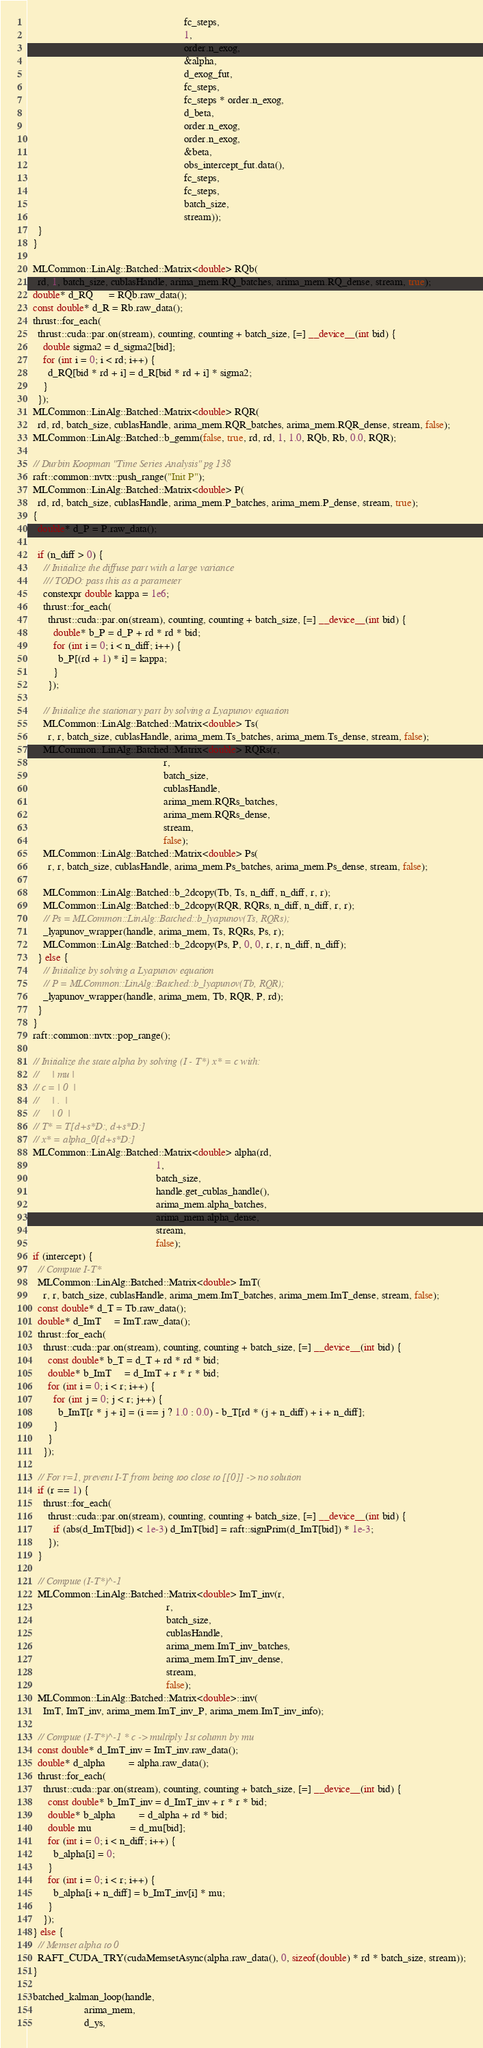<code> <loc_0><loc_0><loc_500><loc_500><_Cuda_>                                                             fc_steps,
                                                             1,
                                                             order.n_exog,
                                                             &alpha,
                                                             d_exog_fut,
                                                             fc_steps,
                                                             fc_steps * order.n_exog,
                                                             d_beta,
                                                             order.n_exog,
                                                             order.n_exog,
                                                             &beta,
                                                             obs_intercept_fut.data(),
                                                             fc_steps,
                                                             fc_steps,
                                                             batch_size,
                                                             stream));
    }
  }

  MLCommon::LinAlg::Batched::Matrix<double> RQb(
    rd, 1, batch_size, cublasHandle, arima_mem.RQ_batches, arima_mem.RQ_dense, stream, true);
  double* d_RQ      = RQb.raw_data();
  const double* d_R = Rb.raw_data();
  thrust::for_each(
    thrust::cuda::par.on(stream), counting, counting + batch_size, [=] __device__(int bid) {
      double sigma2 = d_sigma2[bid];
      for (int i = 0; i < rd; i++) {
        d_RQ[bid * rd + i] = d_R[bid * rd + i] * sigma2;
      }
    });
  MLCommon::LinAlg::Batched::Matrix<double> RQR(
    rd, rd, batch_size, cublasHandle, arima_mem.RQR_batches, arima_mem.RQR_dense, stream, false);
  MLCommon::LinAlg::Batched::b_gemm(false, true, rd, rd, 1, 1.0, RQb, Rb, 0.0, RQR);

  // Durbin Koopman "Time Series Analysis" pg 138
  raft::common::nvtx::push_range("Init P");
  MLCommon::LinAlg::Batched::Matrix<double> P(
    rd, rd, batch_size, cublasHandle, arima_mem.P_batches, arima_mem.P_dense, stream, true);
  {
    double* d_P = P.raw_data();

    if (n_diff > 0) {
      // Initialize the diffuse part with a large variance
      /// TODO: pass this as a parameter
      constexpr double kappa = 1e6;
      thrust::for_each(
        thrust::cuda::par.on(stream), counting, counting + batch_size, [=] __device__(int bid) {
          double* b_P = d_P + rd * rd * bid;
          for (int i = 0; i < n_diff; i++) {
            b_P[(rd + 1) * i] = kappa;
          }
        });

      // Initialize the stationary part by solving a Lyapunov equation
      MLCommon::LinAlg::Batched::Matrix<double> Ts(
        r, r, batch_size, cublasHandle, arima_mem.Ts_batches, arima_mem.Ts_dense, stream, false);
      MLCommon::LinAlg::Batched::Matrix<double> RQRs(r,
                                                     r,
                                                     batch_size,
                                                     cublasHandle,
                                                     arima_mem.RQRs_batches,
                                                     arima_mem.RQRs_dense,
                                                     stream,
                                                     false);
      MLCommon::LinAlg::Batched::Matrix<double> Ps(
        r, r, batch_size, cublasHandle, arima_mem.Ps_batches, arima_mem.Ps_dense, stream, false);

      MLCommon::LinAlg::Batched::b_2dcopy(Tb, Ts, n_diff, n_diff, r, r);
      MLCommon::LinAlg::Batched::b_2dcopy(RQR, RQRs, n_diff, n_diff, r, r);
      // Ps = MLCommon::LinAlg::Batched::b_lyapunov(Ts, RQRs);
      _lyapunov_wrapper(handle, arima_mem, Ts, RQRs, Ps, r);
      MLCommon::LinAlg::Batched::b_2dcopy(Ps, P, 0, 0, r, r, n_diff, n_diff);
    } else {
      // Initialize by solving a Lyapunov equation
      // P = MLCommon::LinAlg::Batched::b_lyapunov(Tb, RQR);
      _lyapunov_wrapper(handle, arima_mem, Tb, RQR, P, rd);
    }
  }
  raft::common::nvtx::pop_range();

  // Initialize the state alpha by solving (I - T*) x* = c with:
  //     | mu |
  // c = | 0  |
  //     | .  |
  //     | 0  |
  // T* = T[d+s*D:, d+s*D:]
  // x* = alpha_0[d+s*D:]
  MLCommon::LinAlg::Batched::Matrix<double> alpha(rd,
                                                  1,
                                                  batch_size,
                                                  handle.get_cublas_handle(),
                                                  arima_mem.alpha_batches,
                                                  arima_mem.alpha_dense,
                                                  stream,
                                                  false);
  if (intercept) {
    // Compute I-T*
    MLCommon::LinAlg::Batched::Matrix<double> ImT(
      r, r, batch_size, cublasHandle, arima_mem.ImT_batches, arima_mem.ImT_dense, stream, false);
    const double* d_T = Tb.raw_data();
    double* d_ImT     = ImT.raw_data();
    thrust::for_each(
      thrust::cuda::par.on(stream), counting, counting + batch_size, [=] __device__(int bid) {
        const double* b_T = d_T + rd * rd * bid;
        double* b_ImT     = d_ImT + r * r * bid;
        for (int i = 0; i < r; i++) {
          for (int j = 0; j < r; j++) {
            b_ImT[r * j + i] = (i == j ? 1.0 : 0.0) - b_T[rd * (j + n_diff) + i + n_diff];
          }
        }
      });

    // For r=1, prevent I-T from being too close to [[0]] -> no solution
    if (r == 1) {
      thrust::for_each(
        thrust::cuda::par.on(stream), counting, counting + batch_size, [=] __device__(int bid) {
          if (abs(d_ImT[bid]) < 1e-3) d_ImT[bid] = raft::signPrim(d_ImT[bid]) * 1e-3;
        });
    }

    // Compute (I-T*)^-1
    MLCommon::LinAlg::Batched::Matrix<double> ImT_inv(r,
                                                      r,
                                                      batch_size,
                                                      cublasHandle,
                                                      arima_mem.ImT_inv_batches,
                                                      arima_mem.ImT_inv_dense,
                                                      stream,
                                                      false);
    MLCommon::LinAlg::Batched::Matrix<double>::inv(
      ImT, ImT_inv, arima_mem.ImT_inv_P, arima_mem.ImT_inv_info);

    // Compute (I-T*)^-1 * c -> multiply 1st column by mu
    const double* d_ImT_inv = ImT_inv.raw_data();
    double* d_alpha         = alpha.raw_data();
    thrust::for_each(
      thrust::cuda::par.on(stream), counting, counting + batch_size, [=] __device__(int bid) {
        const double* b_ImT_inv = d_ImT_inv + r * r * bid;
        double* b_alpha         = d_alpha + rd * bid;
        double mu               = d_mu[bid];
        for (int i = 0; i < n_diff; i++) {
          b_alpha[i] = 0;
        }
        for (int i = 0; i < r; i++) {
          b_alpha[i + n_diff] = b_ImT_inv[i] * mu;
        }
      });
  } else {
    // Memset alpha to 0
    RAFT_CUDA_TRY(cudaMemsetAsync(alpha.raw_data(), 0, sizeof(double) * rd * batch_size, stream));
  }

  batched_kalman_loop(handle,
                      arima_mem,
                      d_ys,</code> 